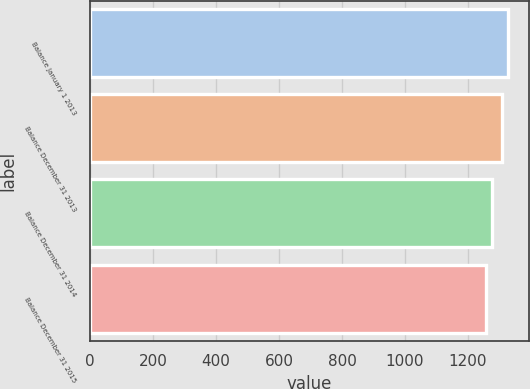Convert chart. <chart><loc_0><loc_0><loc_500><loc_500><bar_chart><fcel>Balance January 1 2013<fcel>Balance December 31 2013<fcel>Balance December 31 2014<fcel>Balance December 31 2015<nl><fcel>1328<fcel>1307<fcel>1275<fcel>1256<nl></chart> 